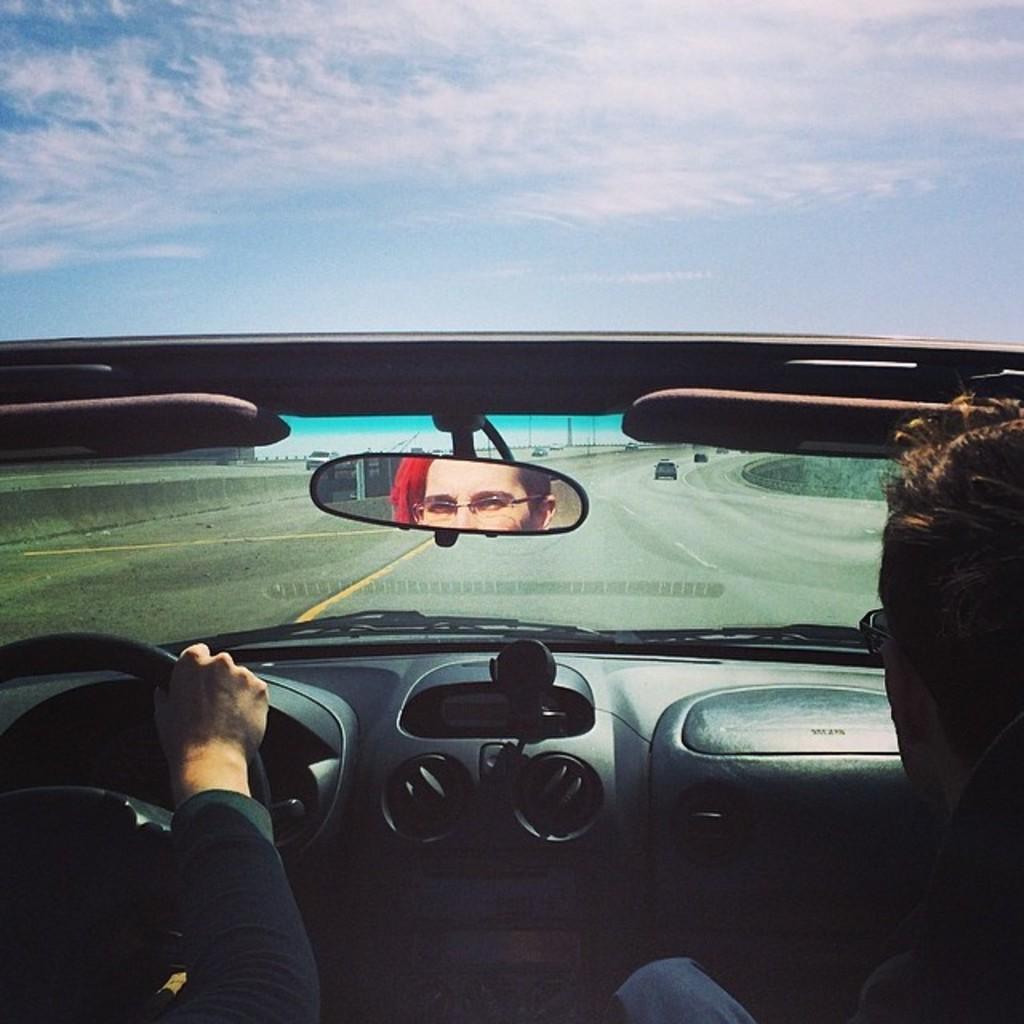Could you give a brief overview of what you see in this image? This is the picture outside of the city. There are many cars passing on the road, on the right side of the road there are two persons in a car one is driving the car. At the top of the picture there is a blue sky with white clouds. 